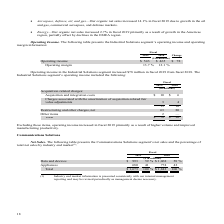According to Te Connectivity's financial document, What was the change in Operating income in the Industrial Solutions segment in 2019? increased $78 million. The document states: "rating income in the Industrial Solutions segment increased $78 million in fiscal 2019 from fiscal 2018. The..." Also, Why did operating income increase in fiscal 2019? primarily as a result of higher volume and improved manufacturing productivity.. The document states: "e items, operating income increased in fiscal 2019 primarily as a result of higher volume and improved manufacturing productivity...." Also, For which years was the operating income in the Industrial Solutions segment calculated? The document shows two values: 2019 and 2018. From the document: "2019 2018 Change 2019 2018 Change..." Additionally, In which year was Acquisition and integration costs larger? According to the financial document, 2019. The relevant text states: "2019 2018 Change..." Also, can you calculate: What was the change in Acquisition and integration costs in 2019 from 2018? Based on the calculation: 10-6, the result is 4 (in millions). This is based on the information: "Acquisition and integration costs $ 10 $ 6 Acquisition and integration costs $ 10 $ 6..." The key data points involved are: 10, 6. Also, can you calculate: What was the percentage change in Acquisition and integration costs in 2019 from 2018? To answer this question, I need to perform calculations using the financial data. The calculation is: (10-6)/6, which equals 66.67 (percentage). This is based on the information: "Acquisition and integration costs $ 10 $ 6 Acquisition and integration costs $ 10 $ 6..." The key data points involved are: 10. 